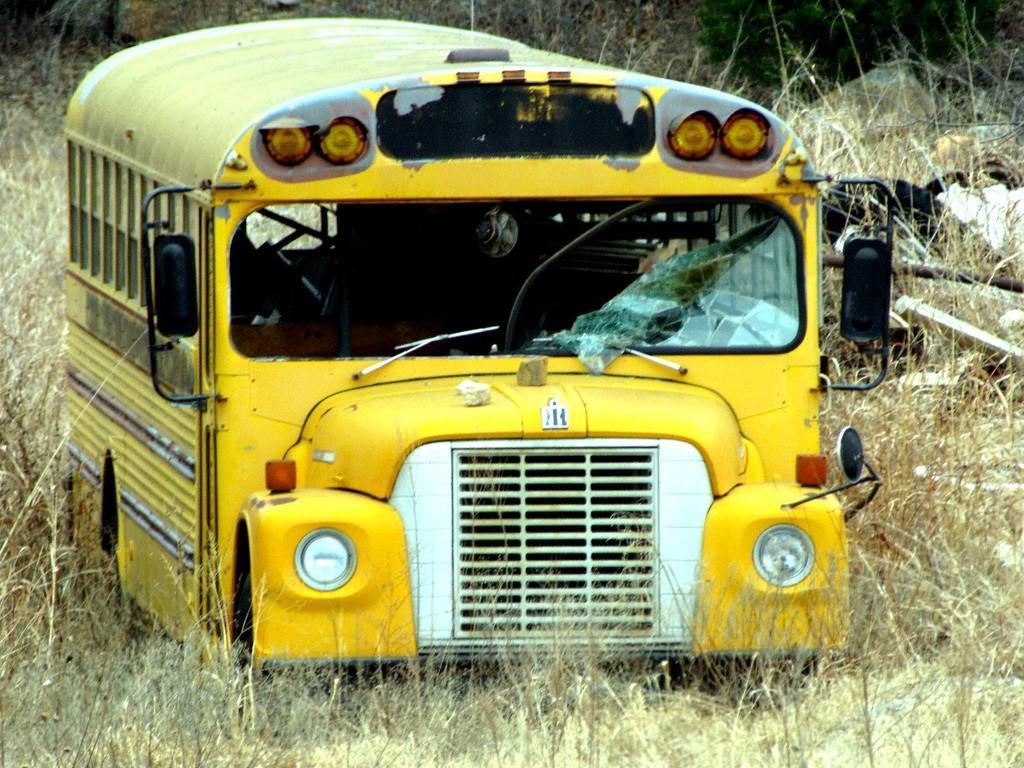Can you describe this image briefly? This picture is clicked outside and we can see the dry stems and in the center there is a yellow color vehicle parked on the ground and we can see the broken glass of the vehicle. In the background we can see some objects lying on the ground and we can see the green leaves. 